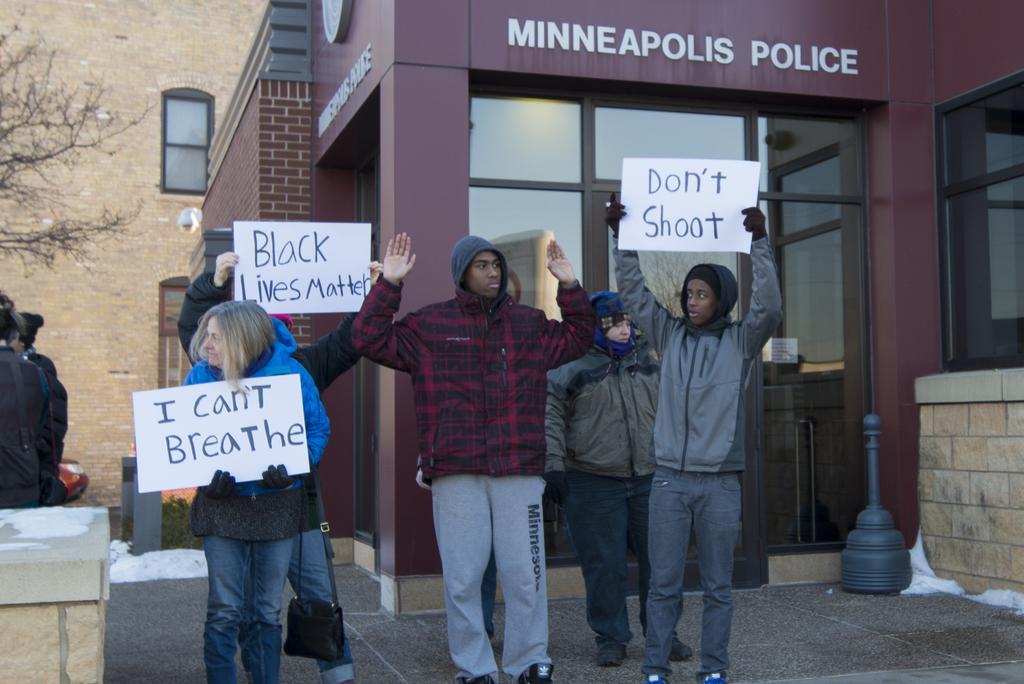Could you give a brief overview of what you see in this image? In this image we can see there are a few people standing and holding a poster with some text on it, behind them there is a building and a tree. 